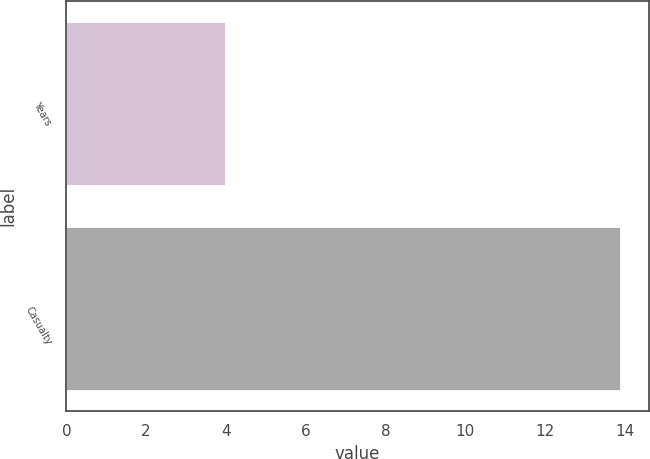<chart> <loc_0><loc_0><loc_500><loc_500><bar_chart><fcel>Years<fcel>Casualty<nl><fcel>4<fcel>13.9<nl></chart> 